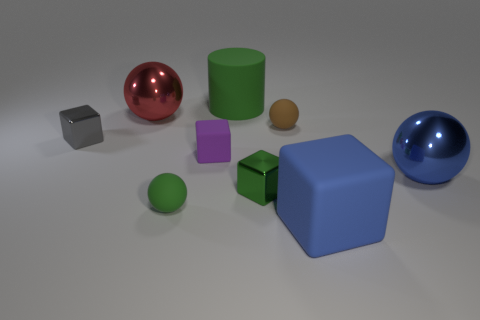Is there any other thing that is made of the same material as the tiny green sphere?
Make the answer very short. Yes. What number of large shiny spheres are behind the big blue sphere?
Your answer should be compact. 1. What is the size of the purple object that is the same shape as the blue rubber thing?
Give a very brief answer. Small. How big is the matte thing that is both on the right side of the small green block and in front of the blue metal object?
Provide a short and direct response. Large. There is a cylinder; does it have the same color as the matte sphere that is in front of the tiny gray object?
Provide a short and direct response. Yes. What number of yellow things are either big metal cylinders or large balls?
Your answer should be very brief. 0. What is the shape of the tiny green metallic object?
Keep it short and to the point. Cube. How many other objects are there of the same shape as the gray metallic object?
Ensure brevity in your answer.  3. There is a metallic object that is on the right side of the tiny brown rubber ball; what is its color?
Your answer should be compact. Blue. Are the brown thing and the tiny green sphere made of the same material?
Offer a terse response. Yes. 